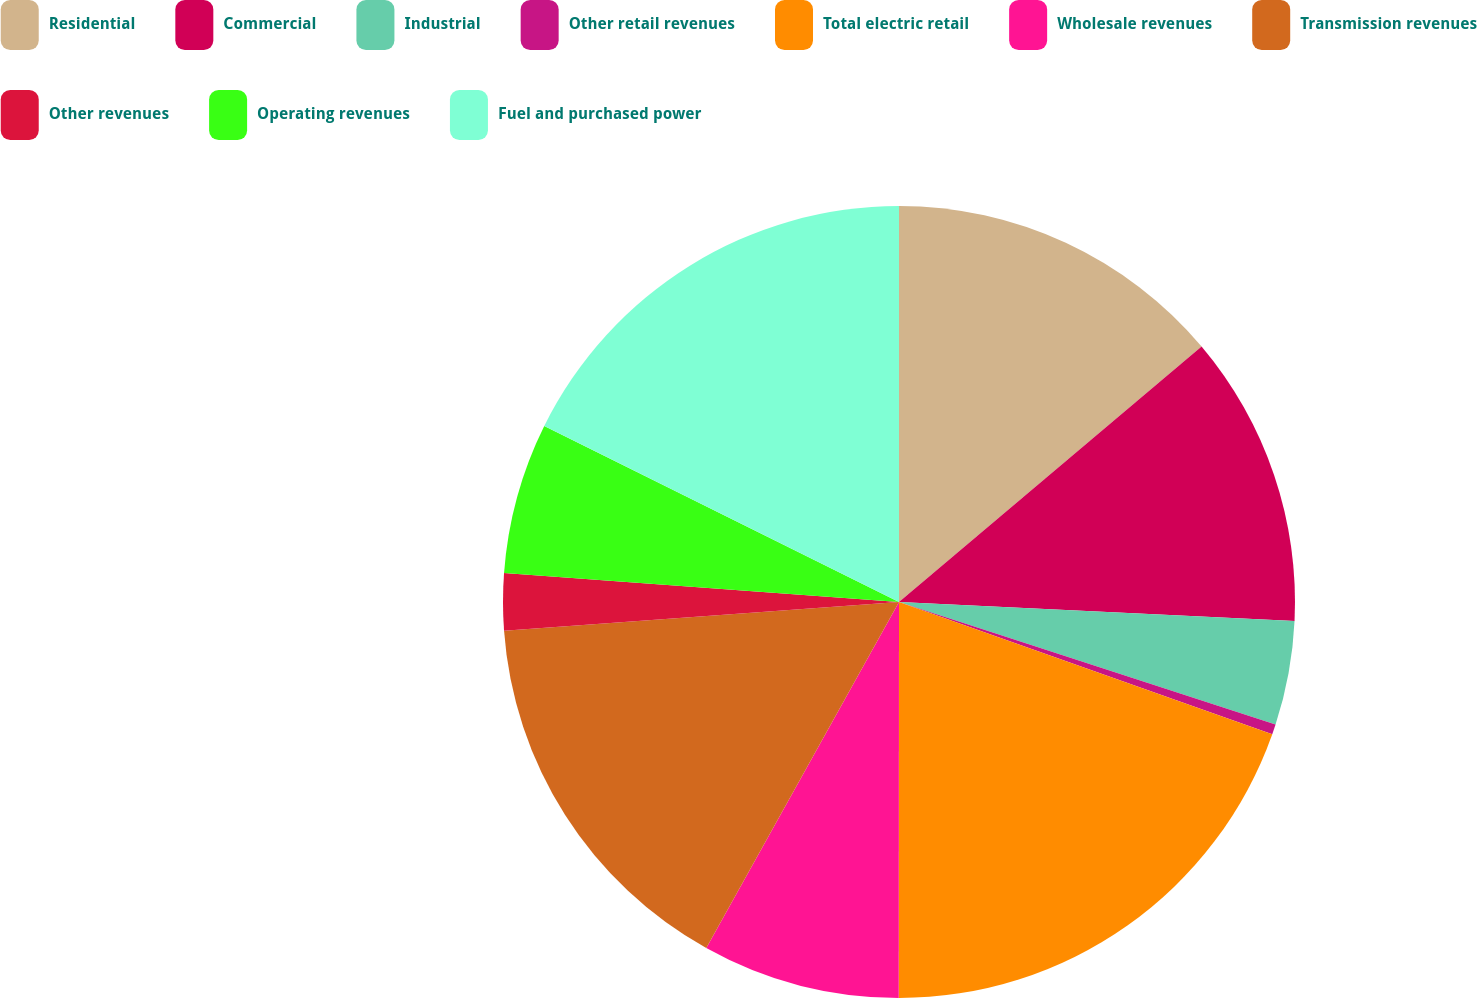Convert chart. <chart><loc_0><loc_0><loc_500><loc_500><pie_chart><fcel>Residential<fcel>Commercial<fcel>Industrial<fcel>Other retail revenues<fcel>Total electric retail<fcel>Wholesale revenues<fcel>Transmission revenues<fcel>Other revenues<fcel>Operating revenues<fcel>Fuel and purchased power<nl><fcel>13.84%<fcel>11.92%<fcel>4.25%<fcel>0.41%<fcel>19.59%<fcel>8.08%<fcel>15.75%<fcel>2.33%<fcel>6.16%<fcel>17.67%<nl></chart> 